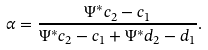Convert formula to latex. <formula><loc_0><loc_0><loc_500><loc_500>\alpha = \frac { \Psi ^ { * } c _ { 2 } - c _ { 1 } } { \Psi ^ { * } c _ { 2 } - c _ { 1 } + \Psi ^ { * } d _ { 2 } - d _ { 1 } } .</formula> 